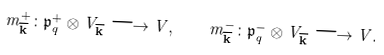Convert formula to latex. <formula><loc_0><loc_0><loc_500><loc_500>m ^ { + } _ { \overline { \mathbf k } } \colon \mathfrak { p } _ { q } ^ { + } \otimes V _ { \overline { \mathbf k } } \longrightarrow V , \quad m ^ { - } _ { \overline { \mathbf k } } \colon \mathfrak { p } _ { q } ^ { - } \otimes V _ { \overline { \mathbf k } } \longrightarrow V .</formula> 